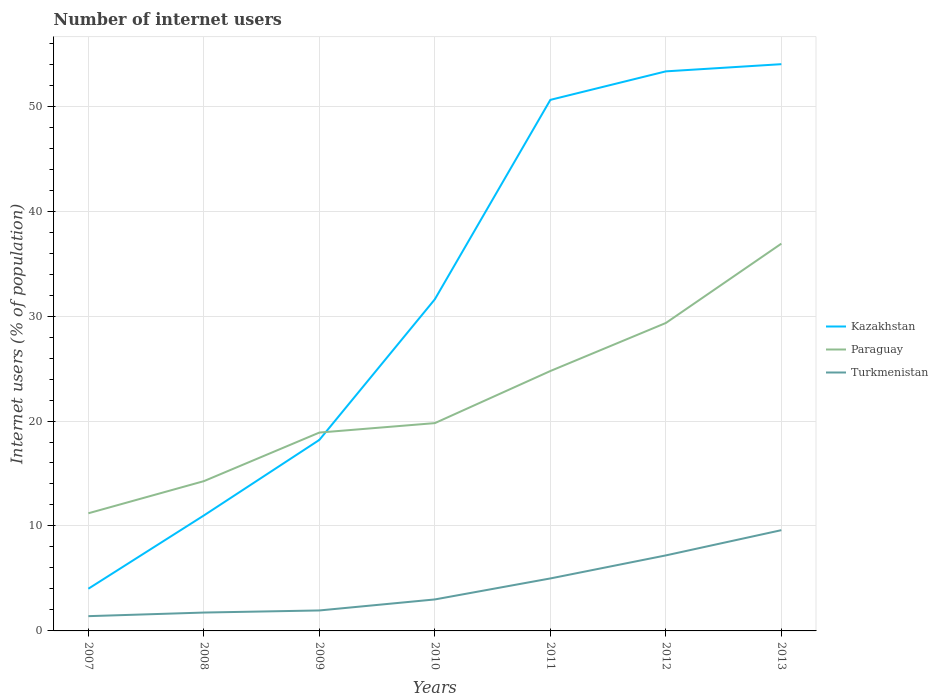How many different coloured lines are there?
Provide a short and direct response. 3. Does the line corresponding to Kazakhstan intersect with the line corresponding to Turkmenistan?
Provide a short and direct response. No. Across all years, what is the maximum number of internet users in Kazakhstan?
Your response must be concise. 4.02. What is the total number of internet users in Turkmenistan in the graph?
Give a very brief answer. -0.2. What is the difference between the highest and the second highest number of internet users in Turkmenistan?
Provide a short and direct response. 8.19. How many years are there in the graph?
Your answer should be compact. 7. What is the difference between two consecutive major ticks on the Y-axis?
Ensure brevity in your answer.  10. Does the graph contain any zero values?
Your response must be concise. No. How many legend labels are there?
Provide a short and direct response. 3. How are the legend labels stacked?
Your response must be concise. Vertical. What is the title of the graph?
Offer a very short reply. Number of internet users. What is the label or title of the X-axis?
Ensure brevity in your answer.  Years. What is the label or title of the Y-axis?
Your response must be concise. Internet users (% of population). What is the Internet users (% of population) of Kazakhstan in 2007?
Provide a short and direct response. 4.02. What is the Internet users (% of population) in Paraguay in 2007?
Your response must be concise. 11.21. What is the Internet users (% of population) in Turkmenistan in 2007?
Make the answer very short. 1.41. What is the Internet users (% of population) of Paraguay in 2008?
Keep it short and to the point. 14.27. What is the Internet users (% of population) in Kazakhstan in 2009?
Your answer should be very brief. 18.2. What is the Internet users (% of population) in Paraguay in 2009?
Offer a very short reply. 18.9. What is the Internet users (% of population) in Turkmenistan in 2009?
Your answer should be compact. 1.95. What is the Internet users (% of population) in Kazakhstan in 2010?
Your response must be concise. 31.6. What is the Internet users (% of population) of Paraguay in 2010?
Make the answer very short. 19.8. What is the Internet users (% of population) in Turkmenistan in 2010?
Your response must be concise. 3. What is the Internet users (% of population) of Kazakhstan in 2011?
Make the answer very short. 50.6. What is the Internet users (% of population) in Paraguay in 2011?
Provide a short and direct response. 24.76. What is the Internet users (% of population) of Kazakhstan in 2012?
Provide a short and direct response. 53.32. What is the Internet users (% of population) in Paraguay in 2012?
Offer a terse response. 29.34. What is the Internet users (% of population) in Turkmenistan in 2012?
Offer a terse response. 7.2. What is the Internet users (% of population) in Paraguay in 2013?
Provide a succinct answer. 36.9. What is the Internet users (% of population) in Turkmenistan in 2013?
Provide a succinct answer. 9.6. Across all years, what is the maximum Internet users (% of population) in Paraguay?
Provide a short and direct response. 36.9. Across all years, what is the minimum Internet users (% of population) in Kazakhstan?
Your answer should be very brief. 4.02. Across all years, what is the minimum Internet users (% of population) in Paraguay?
Offer a terse response. 11.21. Across all years, what is the minimum Internet users (% of population) of Turkmenistan?
Ensure brevity in your answer.  1.41. What is the total Internet users (% of population) of Kazakhstan in the graph?
Make the answer very short. 222.74. What is the total Internet users (% of population) of Paraguay in the graph?
Give a very brief answer. 155.18. What is the total Internet users (% of population) in Turkmenistan in the graph?
Offer a terse response. 29.9. What is the difference between the Internet users (% of population) in Kazakhstan in 2007 and that in 2008?
Your answer should be very brief. -6.98. What is the difference between the Internet users (% of population) of Paraguay in 2007 and that in 2008?
Ensure brevity in your answer.  -3.06. What is the difference between the Internet users (% of population) in Turkmenistan in 2007 and that in 2008?
Offer a very short reply. -0.34. What is the difference between the Internet users (% of population) of Kazakhstan in 2007 and that in 2009?
Offer a terse response. -14.18. What is the difference between the Internet users (% of population) of Paraguay in 2007 and that in 2009?
Give a very brief answer. -7.69. What is the difference between the Internet users (% of population) of Turkmenistan in 2007 and that in 2009?
Your answer should be compact. -0.54. What is the difference between the Internet users (% of population) in Kazakhstan in 2007 and that in 2010?
Provide a short and direct response. -27.58. What is the difference between the Internet users (% of population) in Paraguay in 2007 and that in 2010?
Your response must be concise. -8.59. What is the difference between the Internet users (% of population) in Turkmenistan in 2007 and that in 2010?
Your answer should be very brief. -1.59. What is the difference between the Internet users (% of population) in Kazakhstan in 2007 and that in 2011?
Ensure brevity in your answer.  -46.58. What is the difference between the Internet users (% of population) of Paraguay in 2007 and that in 2011?
Make the answer very short. -13.55. What is the difference between the Internet users (% of population) in Turkmenistan in 2007 and that in 2011?
Your response must be concise. -3.59. What is the difference between the Internet users (% of population) of Kazakhstan in 2007 and that in 2012?
Make the answer very short. -49.3. What is the difference between the Internet users (% of population) of Paraguay in 2007 and that in 2012?
Make the answer very short. -18.13. What is the difference between the Internet users (% of population) in Turkmenistan in 2007 and that in 2012?
Offer a terse response. -5.79. What is the difference between the Internet users (% of population) in Kazakhstan in 2007 and that in 2013?
Your response must be concise. -49.98. What is the difference between the Internet users (% of population) in Paraguay in 2007 and that in 2013?
Provide a short and direct response. -25.69. What is the difference between the Internet users (% of population) in Turkmenistan in 2007 and that in 2013?
Offer a terse response. -8.19. What is the difference between the Internet users (% of population) of Kazakhstan in 2008 and that in 2009?
Make the answer very short. -7.2. What is the difference between the Internet users (% of population) in Paraguay in 2008 and that in 2009?
Keep it short and to the point. -4.63. What is the difference between the Internet users (% of population) of Kazakhstan in 2008 and that in 2010?
Ensure brevity in your answer.  -20.6. What is the difference between the Internet users (% of population) of Paraguay in 2008 and that in 2010?
Ensure brevity in your answer.  -5.53. What is the difference between the Internet users (% of population) in Turkmenistan in 2008 and that in 2010?
Make the answer very short. -1.25. What is the difference between the Internet users (% of population) of Kazakhstan in 2008 and that in 2011?
Make the answer very short. -39.6. What is the difference between the Internet users (% of population) of Paraguay in 2008 and that in 2011?
Your answer should be compact. -10.49. What is the difference between the Internet users (% of population) of Turkmenistan in 2008 and that in 2011?
Your response must be concise. -3.25. What is the difference between the Internet users (% of population) of Kazakhstan in 2008 and that in 2012?
Ensure brevity in your answer.  -42.32. What is the difference between the Internet users (% of population) of Paraguay in 2008 and that in 2012?
Your response must be concise. -15.07. What is the difference between the Internet users (% of population) in Turkmenistan in 2008 and that in 2012?
Offer a very short reply. -5.45. What is the difference between the Internet users (% of population) in Kazakhstan in 2008 and that in 2013?
Provide a short and direct response. -43. What is the difference between the Internet users (% of population) of Paraguay in 2008 and that in 2013?
Make the answer very short. -22.63. What is the difference between the Internet users (% of population) of Turkmenistan in 2008 and that in 2013?
Keep it short and to the point. -7.85. What is the difference between the Internet users (% of population) in Paraguay in 2009 and that in 2010?
Ensure brevity in your answer.  -0.9. What is the difference between the Internet users (% of population) in Turkmenistan in 2009 and that in 2010?
Keep it short and to the point. -1.05. What is the difference between the Internet users (% of population) in Kazakhstan in 2009 and that in 2011?
Provide a short and direct response. -32.4. What is the difference between the Internet users (% of population) in Paraguay in 2009 and that in 2011?
Provide a short and direct response. -5.86. What is the difference between the Internet users (% of population) in Turkmenistan in 2009 and that in 2011?
Provide a succinct answer. -3.05. What is the difference between the Internet users (% of population) in Kazakhstan in 2009 and that in 2012?
Offer a very short reply. -35.12. What is the difference between the Internet users (% of population) of Paraguay in 2009 and that in 2012?
Ensure brevity in your answer.  -10.44. What is the difference between the Internet users (% of population) in Turkmenistan in 2009 and that in 2012?
Ensure brevity in your answer.  -5.25. What is the difference between the Internet users (% of population) of Kazakhstan in 2009 and that in 2013?
Your answer should be compact. -35.8. What is the difference between the Internet users (% of population) of Turkmenistan in 2009 and that in 2013?
Your response must be concise. -7.65. What is the difference between the Internet users (% of population) of Kazakhstan in 2010 and that in 2011?
Ensure brevity in your answer.  -19. What is the difference between the Internet users (% of population) of Paraguay in 2010 and that in 2011?
Keep it short and to the point. -4.96. What is the difference between the Internet users (% of population) in Kazakhstan in 2010 and that in 2012?
Your answer should be compact. -21.72. What is the difference between the Internet users (% of population) in Paraguay in 2010 and that in 2012?
Your answer should be very brief. -9.54. What is the difference between the Internet users (% of population) in Turkmenistan in 2010 and that in 2012?
Offer a very short reply. -4.2. What is the difference between the Internet users (% of population) in Kazakhstan in 2010 and that in 2013?
Give a very brief answer. -22.4. What is the difference between the Internet users (% of population) in Paraguay in 2010 and that in 2013?
Provide a succinct answer. -17.1. What is the difference between the Internet users (% of population) of Kazakhstan in 2011 and that in 2012?
Provide a short and direct response. -2.72. What is the difference between the Internet users (% of population) of Paraguay in 2011 and that in 2012?
Provide a succinct answer. -4.58. What is the difference between the Internet users (% of population) in Turkmenistan in 2011 and that in 2012?
Offer a very short reply. -2.2. What is the difference between the Internet users (% of population) of Kazakhstan in 2011 and that in 2013?
Your answer should be compact. -3.4. What is the difference between the Internet users (% of population) of Paraguay in 2011 and that in 2013?
Your answer should be compact. -12.14. What is the difference between the Internet users (% of population) of Turkmenistan in 2011 and that in 2013?
Provide a short and direct response. -4.6. What is the difference between the Internet users (% of population) of Kazakhstan in 2012 and that in 2013?
Offer a terse response. -0.68. What is the difference between the Internet users (% of population) of Paraguay in 2012 and that in 2013?
Your answer should be compact. -7.56. What is the difference between the Internet users (% of population) in Turkmenistan in 2012 and that in 2013?
Your answer should be very brief. -2.4. What is the difference between the Internet users (% of population) of Kazakhstan in 2007 and the Internet users (% of population) of Paraguay in 2008?
Give a very brief answer. -10.25. What is the difference between the Internet users (% of population) of Kazakhstan in 2007 and the Internet users (% of population) of Turkmenistan in 2008?
Offer a terse response. 2.27. What is the difference between the Internet users (% of population) in Paraguay in 2007 and the Internet users (% of population) in Turkmenistan in 2008?
Ensure brevity in your answer.  9.46. What is the difference between the Internet users (% of population) in Kazakhstan in 2007 and the Internet users (% of population) in Paraguay in 2009?
Provide a short and direct response. -14.88. What is the difference between the Internet users (% of population) of Kazakhstan in 2007 and the Internet users (% of population) of Turkmenistan in 2009?
Your answer should be very brief. 2.07. What is the difference between the Internet users (% of population) in Paraguay in 2007 and the Internet users (% of population) in Turkmenistan in 2009?
Provide a short and direct response. 9.26. What is the difference between the Internet users (% of population) of Kazakhstan in 2007 and the Internet users (% of population) of Paraguay in 2010?
Offer a very short reply. -15.78. What is the difference between the Internet users (% of population) of Paraguay in 2007 and the Internet users (% of population) of Turkmenistan in 2010?
Make the answer very short. 8.21. What is the difference between the Internet users (% of population) of Kazakhstan in 2007 and the Internet users (% of population) of Paraguay in 2011?
Give a very brief answer. -20.74. What is the difference between the Internet users (% of population) of Kazakhstan in 2007 and the Internet users (% of population) of Turkmenistan in 2011?
Provide a short and direct response. -0.98. What is the difference between the Internet users (% of population) in Paraguay in 2007 and the Internet users (% of population) in Turkmenistan in 2011?
Your answer should be compact. 6.21. What is the difference between the Internet users (% of population) of Kazakhstan in 2007 and the Internet users (% of population) of Paraguay in 2012?
Keep it short and to the point. -25.32. What is the difference between the Internet users (% of population) in Kazakhstan in 2007 and the Internet users (% of population) in Turkmenistan in 2012?
Your response must be concise. -3.18. What is the difference between the Internet users (% of population) in Paraguay in 2007 and the Internet users (% of population) in Turkmenistan in 2012?
Make the answer very short. 4.01. What is the difference between the Internet users (% of population) of Kazakhstan in 2007 and the Internet users (% of population) of Paraguay in 2013?
Ensure brevity in your answer.  -32.88. What is the difference between the Internet users (% of population) of Kazakhstan in 2007 and the Internet users (% of population) of Turkmenistan in 2013?
Your response must be concise. -5.58. What is the difference between the Internet users (% of population) of Paraguay in 2007 and the Internet users (% of population) of Turkmenistan in 2013?
Your answer should be compact. 1.61. What is the difference between the Internet users (% of population) of Kazakhstan in 2008 and the Internet users (% of population) of Paraguay in 2009?
Your response must be concise. -7.9. What is the difference between the Internet users (% of population) of Kazakhstan in 2008 and the Internet users (% of population) of Turkmenistan in 2009?
Ensure brevity in your answer.  9.05. What is the difference between the Internet users (% of population) in Paraguay in 2008 and the Internet users (% of population) in Turkmenistan in 2009?
Make the answer very short. 12.32. What is the difference between the Internet users (% of population) of Kazakhstan in 2008 and the Internet users (% of population) of Turkmenistan in 2010?
Offer a terse response. 8. What is the difference between the Internet users (% of population) in Paraguay in 2008 and the Internet users (% of population) in Turkmenistan in 2010?
Make the answer very short. 11.27. What is the difference between the Internet users (% of population) of Kazakhstan in 2008 and the Internet users (% of population) of Paraguay in 2011?
Make the answer very short. -13.76. What is the difference between the Internet users (% of population) of Paraguay in 2008 and the Internet users (% of population) of Turkmenistan in 2011?
Make the answer very short. 9.27. What is the difference between the Internet users (% of population) in Kazakhstan in 2008 and the Internet users (% of population) in Paraguay in 2012?
Provide a succinct answer. -18.34. What is the difference between the Internet users (% of population) in Kazakhstan in 2008 and the Internet users (% of population) in Turkmenistan in 2012?
Offer a very short reply. 3.8. What is the difference between the Internet users (% of population) in Paraguay in 2008 and the Internet users (% of population) in Turkmenistan in 2012?
Your answer should be very brief. 7.07. What is the difference between the Internet users (% of population) of Kazakhstan in 2008 and the Internet users (% of population) of Paraguay in 2013?
Your answer should be compact. -25.9. What is the difference between the Internet users (% of population) in Paraguay in 2008 and the Internet users (% of population) in Turkmenistan in 2013?
Offer a terse response. 4.67. What is the difference between the Internet users (% of population) of Kazakhstan in 2009 and the Internet users (% of population) of Paraguay in 2011?
Make the answer very short. -6.56. What is the difference between the Internet users (% of population) in Paraguay in 2009 and the Internet users (% of population) in Turkmenistan in 2011?
Offer a very short reply. 13.9. What is the difference between the Internet users (% of population) of Kazakhstan in 2009 and the Internet users (% of population) of Paraguay in 2012?
Offer a terse response. -11.14. What is the difference between the Internet users (% of population) of Kazakhstan in 2009 and the Internet users (% of population) of Turkmenistan in 2012?
Make the answer very short. 11. What is the difference between the Internet users (% of population) in Paraguay in 2009 and the Internet users (% of population) in Turkmenistan in 2012?
Ensure brevity in your answer.  11.7. What is the difference between the Internet users (% of population) of Kazakhstan in 2009 and the Internet users (% of population) of Paraguay in 2013?
Provide a short and direct response. -18.7. What is the difference between the Internet users (% of population) of Paraguay in 2009 and the Internet users (% of population) of Turkmenistan in 2013?
Your response must be concise. 9.3. What is the difference between the Internet users (% of population) in Kazakhstan in 2010 and the Internet users (% of population) in Paraguay in 2011?
Offer a terse response. 6.84. What is the difference between the Internet users (% of population) in Kazakhstan in 2010 and the Internet users (% of population) in Turkmenistan in 2011?
Offer a terse response. 26.6. What is the difference between the Internet users (% of population) in Paraguay in 2010 and the Internet users (% of population) in Turkmenistan in 2011?
Keep it short and to the point. 14.8. What is the difference between the Internet users (% of population) of Kazakhstan in 2010 and the Internet users (% of population) of Paraguay in 2012?
Make the answer very short. 2.26. What is the difference between the Internet users (% of population) in Kazakhstan in 2010 and the Internet users (% of population) in Turkmenistan in 2012?
Your answer should be very brief. 24.4. What is the difference between the Internet users (% of population) in Paraguay in 2010 and the Internet users (% of population) in Turkmenistan in 2012?
Give a very brief answer. 12.6. What is the difference between the Internet users (% of population) of Kazakhstan in 2010 and the Internet users (% of population) of Turkmenistan in 2013?
Your response must be concise. 22. What is the difference between the Internet users (% of population) in Kazakhstan in 2011 and the Internet users (% of population) in Paraguay in 2012?
Offer a terse response. 21.26. What is the difference between the Internet users (% of population) of Kazakhstan in 2011 and the Internet users (% of population) of Turkmenistan in 2012?
Ensure brevity in your answer.  43.4. What is the difference between the Internet users (% of population) in Paraguay in 2011 and the Internet users (% of population) in Turkmenistan in 2012?
Keep it short and to the point. 17.57. What is the difference between the Internet users (% of population) in Kazakhstan in 2011 and the Internet users (% of population) in Turkmenistan in 2013?
Offer a terse response. 41. What is the difference between the Internet users (% of population) in Paraguay in 2011 and the Internet users (% of population) in Turkmenistan in 2013?
Your response must be concise. 15.16. What is the difference between the Internet users (% of population) of Kazakhstan in 2012 and the Internet users (% of population) of Paraguay in 2013?
Offer a very short reply. 16.42. What is the difference between the Internet users (% of population) of Kazakhstan in 2012 and the Internet users (% of population) of Turkmenistan in 2013?
Ensure brevity in your answer.  43.72. What is the difference between the Internet users (% of population) of Paraguay in 2012 and the Internet users (% of population) of Turkmenistan in 2013?
Give a very brief answer. 19.74. What is the average Internet users (% of population) in Kazakhstan per year?
Offer a terse response. 31.82. What is the average Internet users (% of population) in Paraguay per year?
Make the answer very short. 22.17. What is the average Internet users (% of population) of Turkmenistan per year?
Give a very brief answer. 4.27. In the year 2007, what is the difference between the Internet users (% of population) of Kazakhstan and Internet users (% of population) of Paraguay?
Your response must be concise. -7.19. In the year 2007, what is the difference between the Internet users (% of population) in Kazakhstan and Internet users (% of population) in Turkmenistan?
Keep it short and to the point. 2.61. In the year 2007, what is the difference between the Internet users (% of population) of Paraguay and Internet users (% of population) of Turkmenistan?
Make the answer very short. 9.8. In the year 2008, what is the difference between the Internet users (% of population) in Kazakhstan and Internet users (% of population) in Paraguay?
Make the answer very short. -3.27. In the year 2008, what is the difference between the Internet users (% of population) in Kazakhstan and Internet users (% of population) in Turkmenistan?
Offer a terse response. 9.25. In the year 2008, what is the difference between the Internet users (% of population) in Paraguay and Internet users (% of population) in Turkmenistan?
Provide a succinct answer. 12.52. In the year 2009, what is the difference between the Internet users (% of population) of Kazakhstan and Internet users (% of population) of Turkmenistan?
Offer a very short reply. 16.25. In the year 2009, what is the difference between the Internet users (% of population) in Paraguay and Internet users (% of population) in Turkmenistan?
Your answer should be very brief. 16.95. In the year 2010, what is the difference between the Internet users (% of population) of Kazakhstan and Internet users (% of population) of Paraguay?
Provide a succinct answer. 11.8. In the year 2010, what is the difference between the Internet users (% of population) of Kazakhstan and Internet users (% of population) of Turkmenistan?
Give a very brief answer. 28.6. In the year 2011, what is the difference between the Internet users (% of population) in Kazakhstan and Internet users (% of population) in Paraguay?
Your response must be concise. 25.84. In the year 2011, what is the difference between the Internet users (% of population) in Kazakhstan and Internet users (% of population) in Turkmenistan?
Provide a succinct answer. 45.6. In the year 2011, what is the difference between the Internet users (% of population) in Paraguay and Internet users (% of population) in Turkmenistan?
Offer a very short reply. 19.76. In the year 2012, what is the difference between the Internet users (% of population) of Kazakhstan and Internet users (% of population) of Paraguay?
Your answer should be compact. 23.98. In the year 2012, what is the difference between the Internet users (% of population) of Kazakhstan and Internet users (% of population) of Turkmenistan?
Offer a terse response. 46.12. In the year 2012, what is the difference between the Internet users (% of population) of Paraguay and Internet users (% of population) of Turkmenistan?
Your response must be concise. 22.14. In the year 2013, what is the difference between the Internet users (% of population) in Kazakhstan and Internet users (% of population) in Turkmenistan?
Provide a succinct answer. 44.4. In the year 2013, what is the difference between the Internet users (% of population) of Paraguay and Internet users (% of population) of Turkmenistan?
Provide a short and direct response. 27.3. What is the ratio of the Internet users (% of population) in Kazakhstan in 2007 to that in 2008?
Offer a very short reply. 0.37. What is the ratio of the Internet users (% of population) of Paraguay in 2007 to that in 2008?
Ensure brevity in your answer.  0.79. What is the ratio of the Internet users (% of population) in Turkmenistan in 2007 to that in 2008?
Offer a terse response. 0.8. What is the ratio of the Internet users (% of population) of Kazakhstan in 2007 to that in 2009?
Offer a terse response. 0.22. What is the ratio of the Internet users (% of population) in Paraguay in 2007 to that in 2009?
Your response must be concise. 0.59. What is the ratio of the Internet users (% of population) in Turkmenistan in 2007 to that in 2009?
Give a very brief answer. 0.72. What is the ratio of the Internet users (% of population) of Kazakhstan in 2007 to that in 2010?
Provide a short and direct response. 0.13. What is the ratio of the Internet users (% of population) of Paraguay in 2007 to that in 2010?
Keep it short and to the point. 0.57. What is the ratio of the Internet users (% of population) of Turkmenistan in 2007 to that in 2010?
Offer a terse response. 0.47. What is the ratio of the Internet users (% of population) in Kazakhstan in 2007 to that in 2011?
Make the answer very short. 0.08. What is the ratio of the Internet users (% of population) of Paraguay in 2007 to that in 2011?
Offer a very short reply. 0.45. What is the ratio of the Internet users (% of population) of Turkmenistan in 2007 to that in 2011?
Keep it short and to the point. 0.28. What is the ratio of the Internet users (% of population) of Kazakhstan in 2007 to that in 2012?
Make the answer very short. 0.08. What is the ratio of the Internet users (% of population) in Paraguay in 2007 to that in 2012?
Give a very brief answer. 0.38. What is the ratio of the Internet users (% of population) of Turkmenistan in 2007 to that in 2012?
Your answer should be very brief. 0.2. What is the ratio of the Internet users (% of population) in Kazakhstan in 2007 to that in 2013?
Your answer should be very brief. 0.07. What is the ratio of the Internet users (% of population) in Paraguay in 2007 to that in 2013?
Keep it short and to the point. 0.3. What is the ratio of the Internet users (% of population) of Turkmenistan in 2007 to that in 2013?
Make the answer very short. 0.15. What is the ratio of the Internet users (% of population) of Kazakhstan in 2008 to that in 2009?
Your answer should be very brief. 0.6. What is the ratio of the Internet users (% of population) of Paraguay in 2008 to that in 2009?
Your answer should be compact. 0.76. What is the ratio of the Internet users (% of population) in Turkmenistan in 2008 to that in 2009?
Offer a terse response. 0.9. What is the ratio of the Internet users (% of population) of Kazakhstan in 2008 to that in 2010?
Provide a succinct answer. 0.35. What is the ratio of the Internet users (% of population) of Paraguay in 2008 to that in 2010?
Give a very brief answer. 0.72. What is the ratio of the Internet users (% of population) of Turkmenistan in 2008 to that in 2010?
Your response must be concise. 0.58. What is the ratio of the Internet users (% of population) of Kazakhstan in 2008 to that in 2011?
Your answer should be very brief. 0.22. What is the ratio of the Internet users (% of population) in Paraguay in 2008 to that in 2011?
Make the answer very short. 0.58. What is the ratio of the Internet users (% of population) of Kazakhstan in 2008 to that in 2012?
Offer a very short reply. 0.21. What is the ratio of the Internet users (% of population) in Paraguay in 2008 to that in 2012?
Provide a succinct answer. 0.49. What is the ratio of the Internet users (% of population) in Turkmenistan in 2008 to that in 2012?
Your response must be concise. 0.24. What is the ratio of the Internet users (% of population) of Kazakhstan in 2008 to that in 2013?
Offer a very short reply. 0.2. What is the ratio of the Internet users (% of population) in Paraguay in 2008 to that in 2013?
Give a very brief answer. 0.39. What is the ratio of the Internet users (% of population) in Turkmenistan in 2008 to that in 2013?
Offer a very short reply. 0.18. What is the ratio of the Internet users (% of population) of Kazakhstan in 2009 to that in 2010?
Provide a succinct answer. 0.58. What is the ratio of the Internet users (% of population) in Paraguay in 2009 to that in 2010?
Provide a short and direct response. 0.95. What is the ratio of the Internet users (% of population) of Turkmenistan in 2009 to that in 2010?
Your response must be concise. 0.65. What is the ratio of the Internet users (% of population) in Kazakhstan in 2009 to that in 2011?
Make the answer very short. 0.36. What is the ratio of the Internet users (% of population) of Paraguay in 2009 to that in 2011?
Ensure brevity in your answer.  0.76. What is the ratio of the Internet users (% of population) of Turkmenistan in 2009 to that in 2011?
Make the answer very short. 0.39. What is the ratio of the Internet users (% of population) in Kazakhstan in 2009 to that in 2012?
Your answer should be very brief. 0.34. What is the ratio of the Internet users (% of population) in Paraguay in 2009 to that in 2012?
Keep it short and to the point. 0.64. What is the ratio of the Internet users (% of population) in Turkmenistan in 2009 to that in 2012?
Your response must be concise. 0.27. What is the ratio of the Internet users (% of population) in Kazakhstan in 2009 to that in 2013?
Provide a succinct answer. 0.34. What is the ratio of the Internet users (% of population) of Paraguay in 2009 to that in 2013?
Provide a short and direct response. 0.51. What is the ratio of the Internet users (% of population) in Turkmenistan in 2009 to that in 2013?
Keep it short and to the point. 0.2. What is the ratio of the Internet users (% of population) in Kazakhstan in 2010 to that in 2011?
Provide a short and direct response. 0.62. What is the ratio of the Internet users (% of population) in Paraguay in 2010 to that in 2011?
Your answer should be very brief. 0.8. What is the ratio of the Internet users (% of population) of Turkmenistan in 2010 to that in 2011?
Provide a succinct answer. 0.6. What is the ratio of the Internet users (% of population) of Kazakhstan in 2010 to that in 2012?
Keep it short and to the point. 0.59. What is the ratio of the Internet users (% of population) of Paraguay in 2010 to that in 2012?
Ensure brevity in your answer.  0.67. What is the ratio of the Internet users (% of population) in Turkmenistan in 2010 to that in 2012?
Your answer should be compact. 0.42. What is the ratio of the Internet users (% of population) of Kazakhstan in 2010 to that in 2013?
Provide a succinct answer. 0.59. What is the ratio of the Internet users (% of population) in Paraguay in 2010 to that in 2013?
Keep it short and to the point. 0.54. What is the ratio of the Internet users (% of population) of Turkmenistan in 2010 to that in 2013?
Make the answer very short. 0.31. What is the ratio of the Internet users (% of population) in Kazakhstan in 2011 to that in 2012?
Provide a succinct answer. 0.95. What is the ratio of the Internet users (% of population) of Paraguay in 2011 to that in 2012?
Provide a succinct answer. 0.84. What is the ratio of the Internet users (% of population) in Turkmenistan in 2011 to that in 2012?
Ensure brevity in your answer.  0.69. What is the ratio of the Internet users (% of population) of Kazakhstan in 2011 to that in 2013?
Offer a terse response. 0.94. What is the ratio of the Internet users (% of population) of Paraguay in 2011 to that in 2013?
Make the answer very short. 0.67. What is the ratio of the Internet users (% of population) of Turkmenistan in 2011 to that in 2013?
Provide a short and direct response. 0.52. What is the ratio of the Internet users (% of population) of Kazakhstan in 2012 to that in 2013?
Your answer should be compact. 0.99. What is the ratio of the Internet users (% of population) of Paraguay in 2012 to that in 2013?
Ensure brevity in your answer.  0.8. What is the ratio of the Internet users (% of population) in Turkmenistan in 2012 to that in 2013?
Ensure brevity in your answer.  0.75. What is the difference between the highest and the second highest Internet users (% of population) in Kazakhstan?
Keep it short and to the point. 0.68. What is the difference between the highest and the second highest Internet users (% of population) in Paraguay?
Provide a short and direct response. 7.56. What is the difference between the highest and the second highest Internet users (% of population) in Turkmenistan?
Your answer should be compact. 2.4. What is the difference between the highest and the lowest Internet users (% of population) of Kazakhstan?
Offer a very short reply. 49.98. What is the difference between the highest and the lowest Internet users (% of population) in Paraguay?
Provide a succinct answer. 25.69. What is the difference between the highest and the lowest Internet users (% of population) of Turkmenistan?
Your response must be concise. 8.19. 